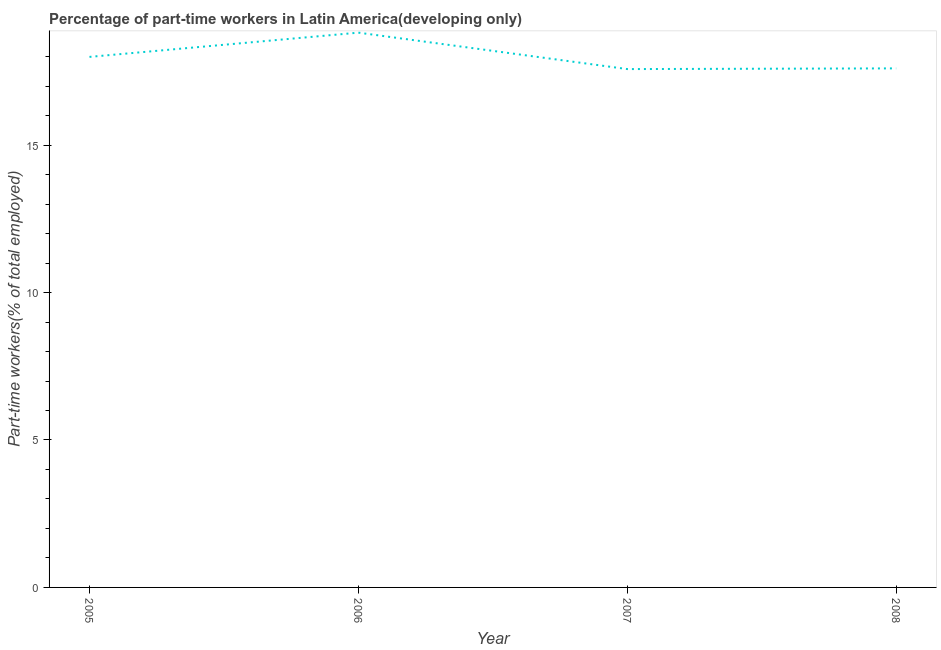What is the percentage of part-time workers in 2006?
Provide a succinct answer. 18.81. Across all years, what is the maximum percentage of part-time workers?
Keep it short and to the point. 18.81. Across all years, what is the minimum percentage of part-time workers?
Ensure brevity in your answer.  17.58. In which year was the percentage of part-time workers minimum?
Your answer should be compact. 2007. What is the sum of the percentage of part-time workers?
Provide a short and direct response. 71.99. What is the difference between the percentage of part-time workers in 2005 and 2006?
Provide a short and direct response. -0.82. What is the average percentage of part-time workers per year?
Give a very brief answer. 18. What is the median percentage of part-time workers?
Your answer should be compact. 17.8. In how many years, is the percentage of part-time workers greater than 15 %?
Provide a short and direct response. 4. What is the ratio of the percentage of part-time workers in 2005 to that in 2006?
Keep it short and to the point. 0.96. Is the difference between the percentage of part-time workers in 2007 and 2008 greater than the difference between any two years?
Offer a terse response. No. What is the difference between the highest and the second highest percentage of part-time workers?
Ensure brevity in your answer.  0.82. Is the sum of the percentage of part-time workers in 2007 and 2008 greater than the maximum percentage of part-time workers across all years?
Give a very brief answer. Yes. What is the difference between the highest and the lowest percentage of part-time workers?
Keep it short and to the point. 1.24. In how many years, is the percentage of part-time workers greater than the average percentage of part-time workers taken over all years?
Your answer should be compact. 1. Does the percentage of part-time workers monotonically increase over the years?
Your response must be concise. No. How many years are there in the graph?
Keep it short and to the point. 4. Are the values on the major ticks of Y-axis written in scientific E-notation?
Your answer should be compact. No. Does the graph contain any zero values?
Your answer should be very brief. No. What is the title of the graph?
Your response must be concise. Percentage of part-time workers in Latin America(developing only). What is the label or title of the Y-axis?
Give a very brief answer. Part-time workers(% of total employed). What is the Part-time workers(% of total employed) of 2005?
Your answer should be very brief. 17.99. What is the Part-time workers(% of total employed) in 2006?
Your answer should be compact. 18.81. What is the Part-time workers(% of total employed) in 2007?
Offer a terse response. 17.58. What is the Part-time workers(% of total employed) in 2008?
Your response must be concise. 17.6. What is the difference between the Part-time workers(% of total employed) in 2005 and 2006?
Your response must be concise. -0.82. What is the difference between the Part-time workers(% of total employed) in 2005 and 2007?
Offer a terse response. 0.41. What is the difference between the Part-time workers(% of total employed) in 2005 and 2008?
Keep it short and to the point. 0.39. What is the difference between the Part-time workers(% of total employed) in 2006 and 2007?
Provide a succinct answer. 1.24. What is the difference between the Part-time workers(% of total employed) in 2006 and 2008?
Your response must be concise. 1.21. What is the difference between the Part-time workers(% of total employed) in 2007 and 2008?
Provide a succinct answer. -0.02. What is the ratio of the Part-time workers(% of total employed) in 2005 to that in 2006?
Your answer should be very brief. 0.96. What is the ratio of the Part-time workers(% of total employed) in 2005 to that in 2007?
Make the answer very short. 1.02. What is the ratio of the Part-time workers(% of total employed) in 2006 to that in 2007?
Keep it short and to the point. 1.07. What is the ratio of the Part-time workers(% of total employed) in 2006 to that in 2008?
Give a very brief answer. 1.07. What is the ratio of the Part-time workers(% of total employed) in 2007 to that in 2008?
Offer a very short reply. 1. 